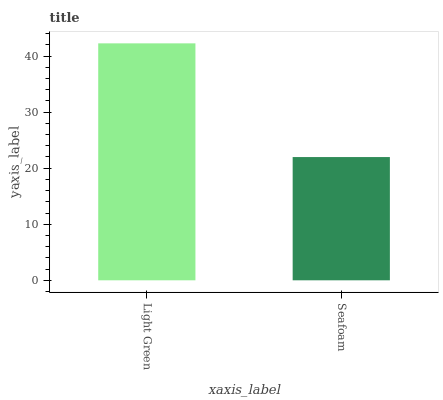Is Seafoam the minimum?
Answer yes or no. Yes. Is Light Green the maximum?
Answer yes or no. Yes. Is Seafoam the maximum?
Answer yes or no. No. Is Light Green greater than Seafoam?
Answer yes or no. Yes. Is Seafoam less than Light Green?
Answer yes or no. Yes. Is Seafoam greater than Light Green?
Answer yes or no. No. Is Light Green less than Seafoam?
Answer yes or no. No. Is Light Green the high median?
Answer yes or no. Yes. Is Seafoam the low median?
Answer yes or no. Yes. Is Seafoam the high median?
Answer yes or no. No. Is Light Green the low median?
Answer yes or no. No. 